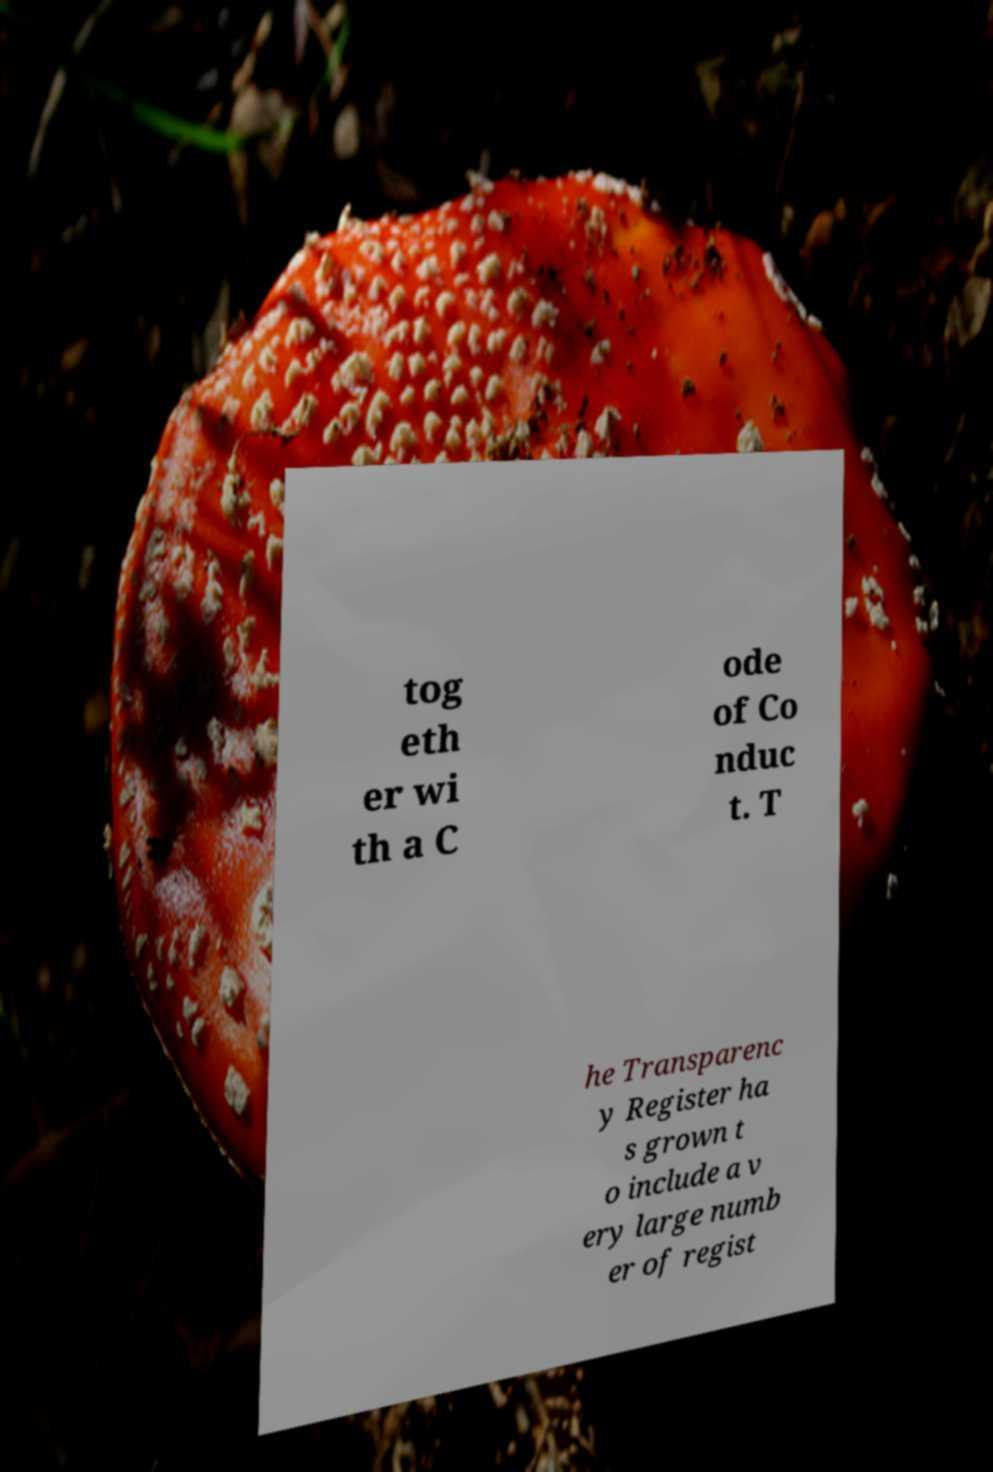Could you extract and type out the text from this image? tog eth er wi th a C ode of Co nduc t. T he Transparenc y Register ha s grown t o include a v ery large numb er of regist 